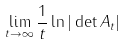<formula> <loc_0><loc_0><loc_500><loc_500>\lim _ { t \rightarrow \infty } \frac { 1 } { t } \ln | \det A _ { t } |</formula> 